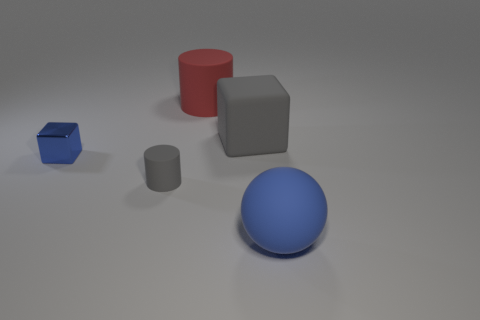Is there another shiny cube that has the same size as the shiny cube?
Keep it short and to the point. No. Do the gray rubber object that is to the left of the large red rubber cylinder and the blue metal object have the same shape?
Provide a succinct answer. No. The large rubber ball has what color?
Keep it short and to the point. Blue. There is a large matte object that is the same color as the tiny metal object; what is its shape?
Your answer should be compact. Sphere. Is there a small brown metallic ball?
Make the answer very short. No. Are there the same number of big rubber blocks and cubes?
Your answer should be compact. No. What is the size of the other cylinder that is made of the same material as the small gray cylinder?
Your answer should be compact. Large. There is a blue thing behind the big matte object that is in front of the cube to the left of the big red object; what is its shape?
Keep it short and to the point. Cube. Is the number of big blue balls on the left side of the blue rubber object the same as the number of brown cylinders?
Provide a succinct answer. Yes. What size is the object that is the same color as the tiny shiny cube?
Provide a succinct answer. Large. 